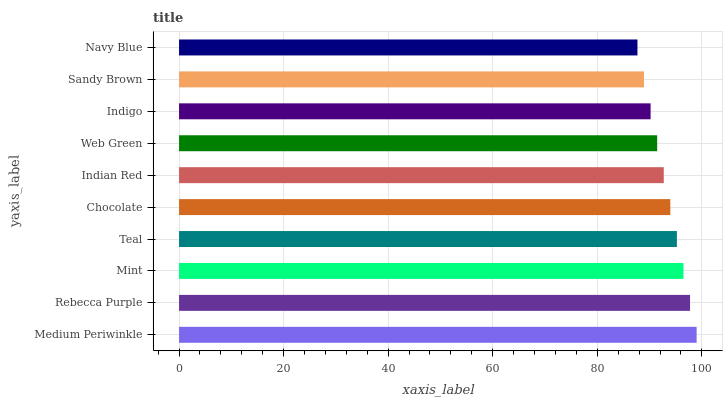Is Navy Blue the minimum?
Answer yes or no. Yes. Is Medium Periwinkle the maximum?
Answer yes or no. Yes. Is Rebecca Purple the minimum?
Answer yes or no. No. Is Rebecca Purple the maximum?
Answer yes or no. No. Is Medium Periwinkle greater than Rebecca Purple?
Answer yes or no. Yes. Is Rebecca Purple less than Medium Periwinkle?
Answer yes or no. Yes. Is Rebecca Purple greater than Medium Periwinkle?
Answer yes or no. No. Is Medium Periwinkle less than Rebecca Purple?
Answer yes or no. No. Is Chocolate the high median?
Answer yes or no. Yes. Is Indian Red the low median?
Answer yes or no. Yes. Is Mint the high median?
Answer yes or no. No. Is Chocolate the low median?
Answer yes or no. No. 